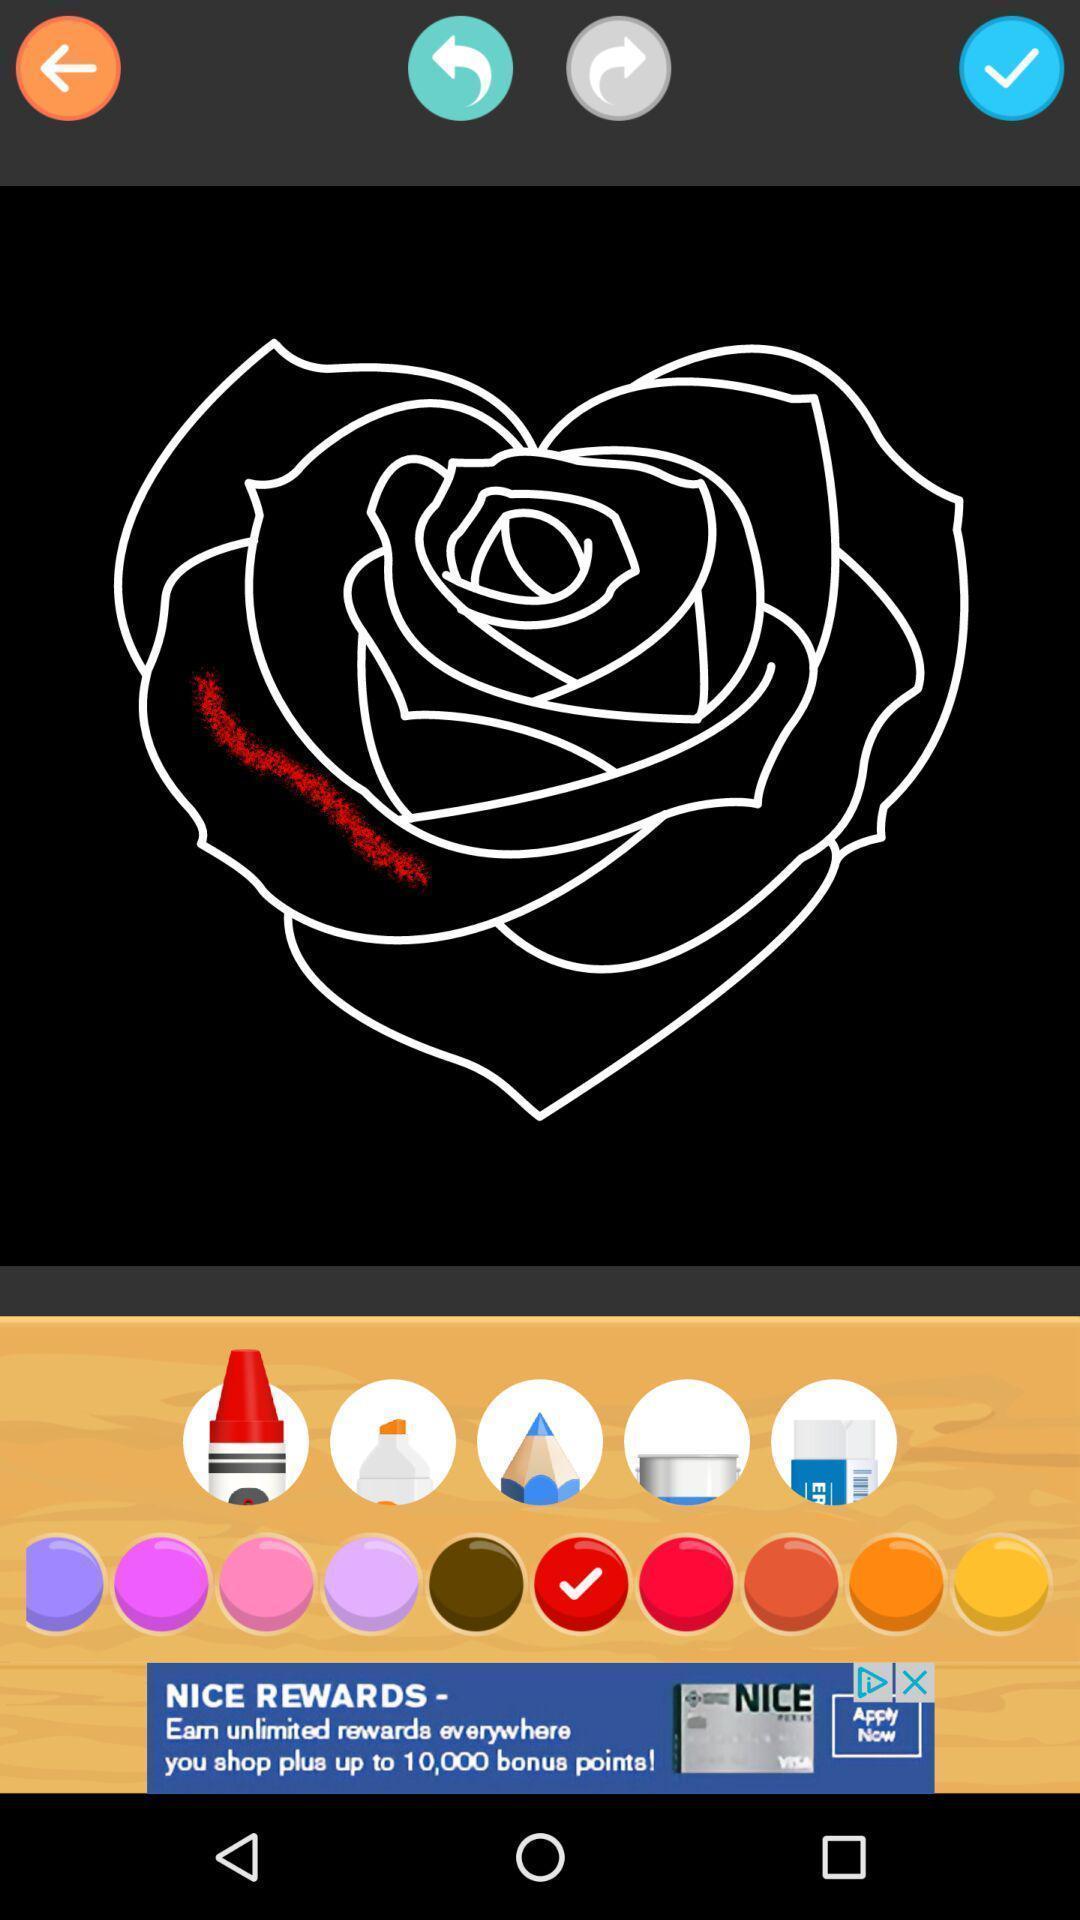Tell me what you see in this picture. Screen shows an art/drawing on a device. 